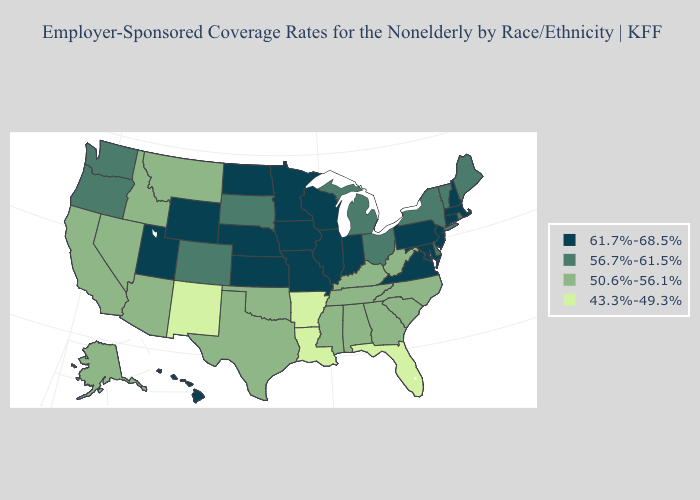Does Minnesota have the highest value in the MidWest?
Answer briefly. Yes. Name the states that have a value in the range 56.7%-61.5%?
Answer briefly. Colorado, Delaware, Maine, Michigan, New York, Ohio, Oregon, Rhode Island, South Dakota, Vermont, Washington. Name the states that have a value in the range 61.7%-68.5%?
Keep it brief. Connecticut, Hawaii, Illinois, Indiana, Iowa, Kansas, Maryland, Massachusetts, Minnesota, Missouri, Nebraska, New Hampshire, New Jersey, North Dakota, Pennsylvania, Utah, Virginia, Wisconsin, Wyoming. What is the lowest value in the USA?
Keep it brief. 43.3%-49.3%. Among the states that border Indiana , does Kentucky have the lowest value?
Quick response, please. Yes. What is the lowest value in the South?
Answer briefly. 43.3%-49.3%. What is the value of Utah?
Concise answer only. 61.7%-68.5%. Among the states that border New Hampshire , which have the highest value?
Answer briefly. Massachusetts. Does Washington have a lower value than Colorado?
Be succinct. No. Does Rhode Island have a higher value than New Jersey?
Be succinct. No. Does New York have a higher value than Kentucky?
Short answer required. Yes. Does Louisiana have the lowest value in the South?
Answer briefly. Yes. What is the value of Nevada?
Be succinct. 50.6%-56.1%. What is the value of Hawaii?
Keep it brief. 61.7%-68.5%. What is the highest value in states that border Illinois?
Answer briefly. 61.7%-68.5%. 